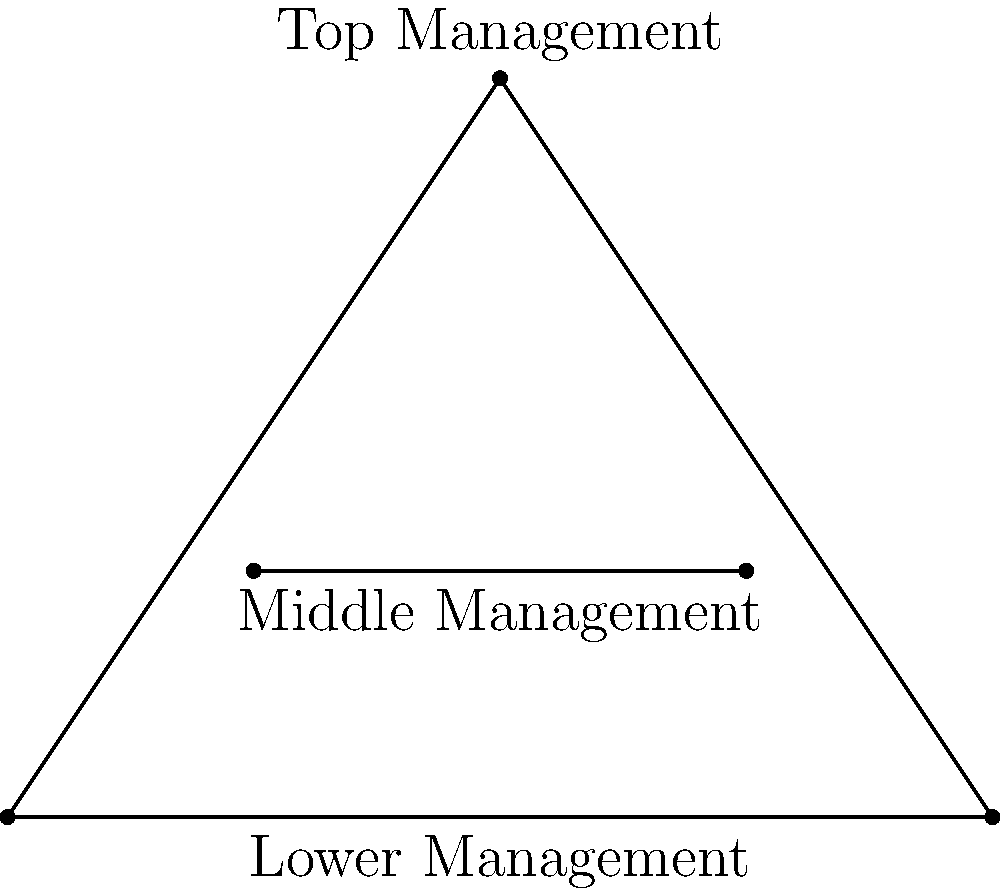In the organizational structure diagram above, which geometric shape best represents the relationship between top management and lower management levels in a government agency? To answer this question, let's analyze the geometric shapes in the diagram:

1. The overall structure is represented by a triangle.
2. The top point of the triangle (C) is labeled "Top Management."
3. The base of the triangle (line AB) is labeled "Lower Management."
4. The line connecting these two levels (top and lower management) forms two sides of the triangle.

The triangle shape in this organizational structure diagram represents a hierarchical relationship between the top and lower management levels. The wide base represents a broader lower management level, while the apex represents a centralized top management.

This triangular structure is commonly used in public administration to depict:
1. Clear lines of authority from top to bottom
2. Decreasing number of positions at higher levels
3. Increasing specialization at lower levels

In government agencies, this structure often reflects:
- Centralized decision-making at the top
- Implementation and day-to-day operations at the lower levels
- A clear chain of command and reporting structure

Therefore, the geometric shape that best represents the relationship between top management and lower management levels in this government agency organizational structure is a triangle.
Answer: Triangle 